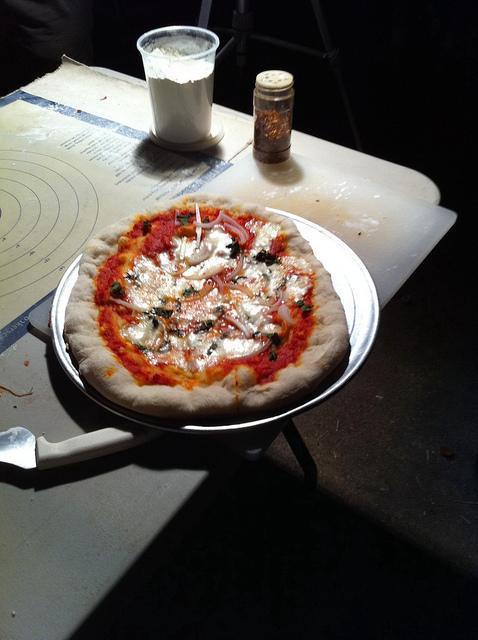How many giraffes are bent down?
Give a very brief answer. 0. 